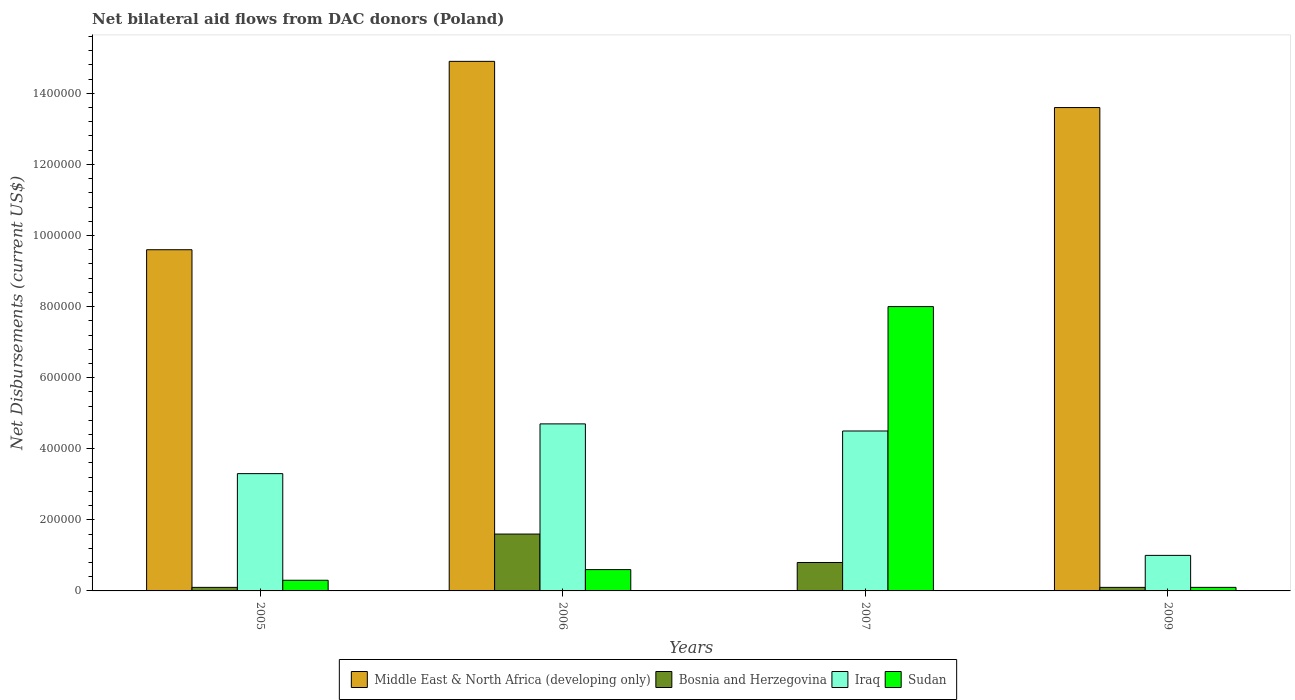How many different coloured bars are there?
Offer a very short reply. 4. How many bars are there on the 1st tick from the left?
Your response must be concise. 4. What is the net bilateral aid flows in Middle East & North Africa (developing only) in 2007?
Your answer should be very brief. 0. Across all years, what is the maximum net bilateral aid flows in Bosnia and Herzegovina?
Give a very brief answer. 1.60e+05. Across all years, what is the minimum net bilateral aid flows in Bosnia and Herzegovina?
Provide a succinct answer. 10000. In which year was the net bilateral aid flows in Sudan maximum?
Provide a short and direct response. 2007. What is the total net bilateral aid flows in Iraq in the graph?
Offer a very short reply. 1.35e+06. What is the difference between the net bilateral aid flows in Iraq in 2005 and that in 2006?
Your answer should be very brief. -1.40e+05. What is the difference between the net bilateral aid flows in Bosnia and Herzegovina in 2007 and the net bilateral aid flows in Sudan in 2005?
Offer a very short reply. 5.00e+04. What is the average net bilateral aid flows in Sudan per year?
Give a very brief answer. 2.25e+05. In the year 2006, what is the difference between the net bilateral aid flows in Bosnia and Herzegovina and net bilateral aid flows in Iraq?
Your response must be concise. -3.10e+05. What is the ratio of the net bilateral aid flows in Middle East & North Africa (developing only) in 2005 to that in 2006?
Keep it short and to the point. 0.64. Is the net bilateral aid flows in Bosnia and Herzegovina in 2007 less than that in 2009?
Keep it short and to the point. No. Is the difference between the net bilateral aid flows in Bosnia and Herzegovina in 2005 and 2006 greater than the difference between the net bilateral aid flows in Iraq in 2005 and 2006?
Your response must be concise. No. What is the difference between the highest and the second highest net bilateral aid flows in Iraq?
Give a very brief answer. 2.00e+04. What is the difference between the highest and the lowest net bilateral aid flows in Iraq?
Your response must be concise. 3.70e+05. In how many years, is the net bilateral aid flows in Iraq greater than the average net bilateral aid flows in Iraq taken over all years?
Your answer should be very brief. 2. Is it the case that in every year, the sum of the net bilateral aid flows in Sudan and net bilateral aid flows in Bosnia and Herzegovina is greater than the sum of net bilateral aid flows in Middle East & North Africa (developing only) and net bilateral aid flows in Iraq?
Your answer should be compact. No. Is it the case that in every year, the sum of the net bilateral aid flows in Sudan and net bilateral aid flows in Iraq is greater than the net bilateral aid flows in Middle East & North Africa (developing only)?
Your answer should be compact. No. How many bars are there?
Your answer should be compact. 15. Are all the bars in the graph horizontal?
Offer a terse response. No. How many years are there in the graph?
Give a very brief answer. 4. Are the values on the major ticks of Y-axis written in scientific E-notation?
Your answer should be compact. No. Does the graph contain any zero values?
Your answer should be compact. Yes. Where does the legend appear in the graph?
Offer a terse response. Bottom center. What is the title of the graph?
Make the answer very short. Net bilateral aid flows from DAC donors (Poland). Does "North America" appear as one of the legend labels in the graph?
Your response must be concise. No. What is the label or title of the X-axis?
Your answer should be compact. Years. What is the label or title of the Y-axis?
Your answer should be very brief. Net Disbursements (current US$). What is the Net Disbursements (current US$) in Middle East & North Africa (developing only) in 2005?
Your answer should be very brief. 9.60e+05. What is the Net Disbursements (current US$) of Iraq in 2005?
Keep it short and to the point. 3.30e+05. What is the Net Disbursements (current US$) of Sudan in 2005?
Make the answer very short. 3.00e+04. What is the Net Disbursements (current US$) of Middle East & North Africa (developing only) in 2006?
Offer a terse response. 1.49e+06. What is the Net Disbursements (current US$) in Bosnia and Herzegovina in 2006?
Make the answer very short. 1.60e+05. What is the Net Disbursements (current US$) in Sudan in 2006?
Ensure brevity in your answer.  6.00e+04. What is the Net Disbursements (current US$) in Iraq in 2007?
Offer a terse response. 4.50e+05. What is the Net Disbursements (current US$) of Middle East & North Africa (developing only) in 2009?
Provide a succinct answer. 1.36e+06. What is the Net Disbursements (current US$) of Iraq in 2009?
Provide a succinct answer. 1.00e+05. Across all years, what is the maximum Net Disbursements (current US$) in Middle East & North Africa (developing only)?
Ensure brevity in your answer.  1.49e+06. Across all years, what is the maximum Net Disbursements (current US$) in Bosnia and Herzegovina?
Offer a terse response. 1.60e+05. Across all years, what is the maximum Net Disbursements (current US$) of Iraq?
Your response must be concise. 4.70e+05. Across all years, what is the minimum Net Disbursements (current US$) in Middle East & North Africa (developing only)?
Your answer should be very brief. 0. Across all years, what is the minimum Net Disbursements (current US$) of Bosnia and Herzegovina?
Keep it short and to the point. 10000. Across all years, what is the minimum Net Disbursements (current US$) of Sudan?
Your answer should be very brief. 10000. What is the total Net Disbursements (current US$) in Middle East & North Africa (developing only) in the graph?
Offer a terse response. 3.81e+06. What is the total Net Disbursements (current US$) in Bosnia and Herzegovina in the graph?
Your answer should be very brief. 2.60e+05. What is the total Net Disbursements (current US$) in Iraq in the graph?
Provide a short and direct response. 1.35e+06. What is the total Net Disbursements (current US$) in Sudan in the graph?
Keep it short and to the point. 9.00e+05. What is the difference between the Net Disbursements (current US$) of Middle East & North Africa (developing only) in 2005 and that in 2006?
Your response must be concise. -5.30e+05. What is the difference between the Net Disbursements (current US$) in Bosnia and Herzegovina in 2005 and that in 2006?
Make the answer very short. -1.50e+05. What is the difference between the Net Disbursements (current US$) in Bosnia and Herzegovina in 2005 and that in 2007?
Provide a succinct answer. -7.00e+04. What is the difference between the Net Disbursements (current US$) in Sudan in 2005 and that in 2007?
Your response must be concise. -7.70e+05. What is the difference between the Net Disbursements (current US$) of Middle East & North Africa (developing only) in 2005 and that in 2009?
Your response must be concise. -4.00e+05. What is the difference between the Net Disbursements (current US$) of Bosnia and Herzegovina in 2005 and that in 2009?
Provide a short and direct response. 0. What is the difference between the Net Disbursements (current US$) of Iraq in 2005 and that in 2009?
Keep it short and to the point. 2.30e+05. What is the difference between the Net Disbursements (current US$) of Sudan in 2006 and that in 2007?
Provide a short and direct response. -7.40e+05. What is the difference between the Net Disbursements (current US$) in Iraq in 2006 and that in 2009?
Provide a succinct answer. 3.70e+05. What is the difference between the Net Disbursements (current US$) of Bosnia and Herzegovina in 2007 and that in 2009?
Give a very brief answer. 7.00e+04. What is the difference between the Net Disbursements (current US$) of Sudan in 2007 and that in 2009?
Offer a terse response. 7.90e+05. What is the difference between the Net Disbursements (current US$) of Middle East & North Africa (developing only) in 2005 and the Net Disbursements (current US$) of Bosnia and Herzegovina in 2006?
Give a very brief answer. 8.00e+05. What is the difference between the Net Disbursements (current US$) of Middle East & North Africa (developing only) in 2005 and the Net Disbursements (current US$) of Iraq in 2006?
Provide a succinct answer. 4.90e+05. What is the difference between the Net Disbursements (current US$) of Middle East & North Africa (developing only) in 2005 and the Net Disbursements (current US$) of Sudan in 2006?
Provide a short and direct response. 9.00e+05. What is the difference between the Net Disbursements (current US$) in Bosnia and Herzegovina in 2005 and the Net Disbursements (current US$) in Iraq in 2006?
Provide a short and direct response. -4.60e+05. What is the difference between the Net Disbursements (current US$) in Bosnia and Herzegovina in 2005 and the Net Disbursements (current US$) in Sudan in 2006?
Your answer should be compact. -5.00e+04. What is the difference between the Net Disbursements (current US$) of Iraq in 2005 and the Net Disbursements (current US$) of Sudan in 2006?
Your response must be concise. 2.70e+05. What is the difference between the Net Disbursements (current US$) in Middle East & North Africa (developing only) in 2005 and the Net Disbursements (current US$) in Bosnia and Herzegovina in 2007?
Your response must be concise. 8.80e+05. What is the difference between the Net Disbursements (current US$) in Middle East & North Africa (developing only) in 2005 and the Net Disbursements (current US$) in Iraq in 2007?
Offer a terse response. 5.10e+05. What is the difference between the Net Disbursements (current US$) of Middle East & North Africa (developing only) in 2005 and the Net Disbursements (current US$) of Sudan in 2007?
Your answer should be compact. 1.60e+05. What is the difference between the Net Disbursements (current US$) of Bosnia and Herzegovina in 2005 and the Net Disbursements (current US$) of Iraq in 2007?
Your answer should be compact. -4.40e+05. What is the difference between the Net Disbursements (current US$) of Bosnia and Herzegovina in 2005 and the Net Disbursements (current US$) of Sudan in 2007?
Your response must be concise. -7.90e+05. What is the difference between the Net Disbursements (current US$) of Iraq in 2005 and the Net Disbursements (current US$) of Sudan in 2007?
Ensure brevity in your answer.  -4.70e+05. What is the difference between the Net Disbursements (current US$) in Middle East & North Africa (developing only) in 2005 and the Net Disbursements (current US$) in Bosnia and Herzegovina in 2009?
Keep it short and to the point. 9.50e+05. What is the difference between the Net Disbursements (current US$) in Middle East & North Africa (developing only) in 2005 and the Net Disbursements (current US$) in Iraq in 2009?
Your answer should be compact. 8.60e+05. What is the difference between the Net Disbursements (current US$) in Middle East & North Africa (developing only) in 2005 and the Net Disbursements (current US$) in Sudan in 2009?
Provide a short and direct response. 9.50e+05. What is the difference between the Net Disbursements (current US$) of Bosnia and Herzegovina in 2005 and the Net Disbursements (current US$) of Iraq in 2009?
Provide a short and direct response. -9.00e+04. What is the difference between the Net Disbursements (current US$) in Bosnia and Herzegovina in 2005 and the Net Disbursements (current US$) in Sudan in 2009?
Provide a short and direct response. 0. What is the difference between the Net Disbursements (current US$) in Iraq in 2005 and the Net Disbursements (current US$) in Sudan in 2009?
Keep it short and to the point. 3.20e+05. What is the difference between the Net Disbursements (current US$) of Middle East & North Africa (developing only) in 2006 and the Net Disbursements (current US$) of Bosnia and Herzegovina in 2007?
Offer a very short reply. 1.41e+06. What is the difference between the Net Disbursements (current US$) in Middle East & North Africa (developing only) in 2006 and the Net Disbursements (current US$) in Iraq in 2007?
Make the answer very short. 1.04e+06. What is the difference between the Net Disbursements (current US$) in Middle East & North Africa (developing only) in 2006 and the Net Disbursements (current US$) in Sudan in 2007?
Provide a short and direct response. 6.90e+05. What is the difference between the Net Disbursements (current US$) of Bosnia and Herzegovina in 2006 and the Net Disbursements (current US$) of Sudan in 2007?
Ensure brevity in your answer.  -6.40e+05. What is the difference between the Net Disbursements (current US$) of Iraq in 2006 and the Net Disbursements (current US$) of Sudan in 2007?
Offer a terse response. -3.30e+05. What is the difference between the Net Disbursements (current US$) in Middle East & North Africa (developing only) in 2006 and the Net Disbursements (current US$) in Bosnia and Herzegovina in 2009?
Your answer should be very brief. 1.48e+06. What is the difference between the Net Disbursements (current US$) of Middle East & North Africa (developing only) in 2006 and the Net Disbursements (current US$) of Iraq in 2009?
Your answer should be very brief. 1.39e+06. What is the difference between the Net Disbursements (current US$) of Middle East & North Africa (developing only) in 2006 and the Net Disbursements (current US$) of Sudan in 2009?
Your response must be concise. 1.48e+06. What is the difference between the Net Disbursements (current US$) in Bosnia and Herzegovina in 2006 and the Net Disbursements (current US$) in Iraq in 2009?
Your response must be concise. 6.00e+04. What is the difference between the Net Disbursements (current US$) of Bosnia and Herzegovina in 2007 and the Net Disbursements (current US$) of Iraq in 2009?
Offer a very short reply. -2.00e+04. What is the average Net Disbursements (current US$) of Middle East & North Africa (developing only) per year?
Your response must be concise. 9.52e+05. What is the average Net Disbursements (current US$) of Bosnia and Herzegovina per year?
Your answer should be very brief. 6.50e+04. What is the average Net Disbursements (current US$) of Iraq per year?
Your response must be concise. 3.38e+05. What is the average Net Disbursements (current US$) in Sudan per year?
Your answer should be very brief. 2.25e+05. In the year 2005, what is the difference between the Net Disbursements (current US$) of Middle East & North Africa (developing only) and Net Disbursements (current US$) of Bosnia and Herzegovina?
Your response must be concise. 9.50e+05. In the year 2005, what is the difference between the Net Disbursements (current US$) of Middle East & North Africa (developing only) and Net Disbursements (current US$) of Iraq?
Your answer should be very brief. 6.30e+05. In the year 2005, what is the difference between the Net Disbursements (current US$) in Middle East & North Africa (developing only) and Net Disbursements (current US$) in Sudan?
Provide a short and direct response. 9.30e+05. In the year 2005, what is the difference between the Net Disbursements (current US$) of Bosnia and Herzegovina and Net Disbursements (current US$) of Iraq?
Give a very brief answer. -3.20e+05. In the year 2005, what is the difference between the Net Disbursements (current US$) of Iraq and Net Disbursements (current US$) of Sudan?
Your answer should be compact. 3.00e+05. In the year 2006, what is the difference between the Net Disbursements (current US$) of Middle East & North Africa (developing only) and Net Disbursements (current US$) of Bosnia and Herzegovina?
Offer a terse response. 1.33e+06. In the year 2006, what is the difference between the Net Disbursements (current US$) in Middle East & North Africa (developing only) and Net Disbursements (current US$) in Iraq?
Provide a short and direct response. 1.02e+06. In the year 2006, what is the difference between the Net Disbursements (current US$) in Middle East & North Africa (developing only) and Net Disbursements (current US$) in Sudan?
Offer a very short reply. 1.43e+06. In the year 2006, what is the difference between the Net Disbursements (current US$) of Bosnia and Herzegovina and Net Disbursements (current US$) of Iraq?
Offer a terse response. -3.10e+05. In the year 2007, what is the difference between the Net Disbursements (current US$) of Bosnia and Herzegovina and Net Disbursements (current US$) of Iraq?
Offer a terse response. -3.70e+05. In the year 2007, what is the difference between the Net Disbursements (current US$) of Bosnia and Herzegovina and Net Disbursements (current US$) of Sudan?
Provide a succinct answer. -7.20e+05. In the year 2007, what is the difference between the Net Disbursements (current US$) in Iraq and Net Disbursements (current US$) in Sudan?
Provide a succinct answer. -3.50e+05. In the year 2009, what is the difference between the Net Disbursements (current US$) of Middle East & North Africa (developing only) and Net Disbursements (current US$) of Bosnia and Herzegovina?
Provide a short and direct response. 1.35e+06. In the year 2009, what is the difference between the Net Disbursements (current US$) of Middle East & North Africa (developing only) and Net Disbursements (current US$) of Iraq?
Your answer should be very brief. 1.26e+06. In the year 2009, what is the difference between the Net Disbursements (current US$) of Middle East & North Africa (developing only) and Net Disbursements (current US$) of Sudan?
Your response must be concise. 1.35e+06. In the year 2009, what is the difference between the Net Disbursements (current US$) of Bosnia and Herzegovina and Net Disbursements (current US$) of Iraq?
Your answer should be compact. -9.00e+04. In the year 2009, what is the difference between the Net Disbursements (current US$) in Bosnia and Herzegovina and Net Disbursements (current US$) in Sudan?
Make the answer very short. 0. What is the ratio of the Net Disbursements (current US$) in Middle East & North Africa (developing only) in 2005 to that in 2006?
Your response must be concise. 0.64. What is the ratio of the Net Disbursements (current US$) of Bosnia and Herzegovina in 2005 to that in 2006?
Give a very brief answer. 0.06. What is the ratio of the Net Disbursements (current US$) in Iraq in 2005 to that in 2006?
Provide a short and direct response. 0.7. What is the ratio of the Net Disbursements (current US$) in Iraq in 2005 to that in 2007?
Offer a very short reply. 0.73. What is the ratio of the Net Disbursements (current US$) of Sudan in 2005 to that in 2007?
Make the answer very short. 0.04. What is the ratio of the Net Disbursements (current US$) in Middle East & North Africa (developing only) in 2005 to that in 2009?
Offer a terse response. 0.71. What is the ratio of the Net Disbursements (current US$) in Iraq in 2005 to that in 2009?
Your answer should be very brief. 3.3. What is the ratio of the Net Disbursements (current US$) in Sudan in 2005 to that in 2009?
Offer a terse response. 3. What is the ratio of the Net Disbursements (current US$) of Bosnia and Herzegovina in 2006 to that in 2007?
Offer a terse response. 2. What is the ratio of the Net Disbursements (current US$) in Iraq in 2006 to that in 2007?
Give a very brief answer. 1.04. What is the ratio of the Net Disbursements (current US$) of Sudan in 2006 to that in 2007?
Offer a terse response. 0.07. What is the ratio of the Net Disbursements (current US$) in Middle East & North Africa (developing only) in 2006 to that in 2009?
Ensure brevity in your answer.  1.1. What is the ratio of the Net Disbursements (current US$) of Bosnia and Herzegovina in 2006 to that in 2009?
Provide a succinct answer. 16. What is the ratio of the Net Disbursements (current US$) of Sudan in 2006 to that in 2009?
Offer a very short reply. 6. What is the ratio of the Net Disbursements (current US$) of Bosnia and Herzegovina in 2007 to that in 2009?
Provide a succinct answer. 8. What is the ratio of the Net Disbursements (current US$) of Iraq in 2007 to that in 2009?
Your answer should be very brief. 4.5. What is the ratio of the Net Disbursements (current US$) in Sudan in 2007 to that in 2009?
Offer a terse response. 80. What is the difference between the highest and the second highest Net Disbursements (current US$) in Bosnia and Herzegovina?
Your answer should be compact. 8.00e+04. What is the difference between the highest and the second highest Net Disbursements (current US$) of Sudan?
Your response must be concise. 7.40e+05. What is the difference between the highest and the lowest Net Disbursements (current US$) of Middle East & North Africa (developing only)?
Ensure brevity in your answer.  1.49e+06. What is the difference between the highest and the lowest Net Disbursements (current US$) in Bosnia and Herzegovina?
Keep it short and to the point. 1.50e+05. What is the difference between the highest and the lowest Net Disbursements (current US$) in Sudan?
Your answer should be very brief. 7.90e+05. 